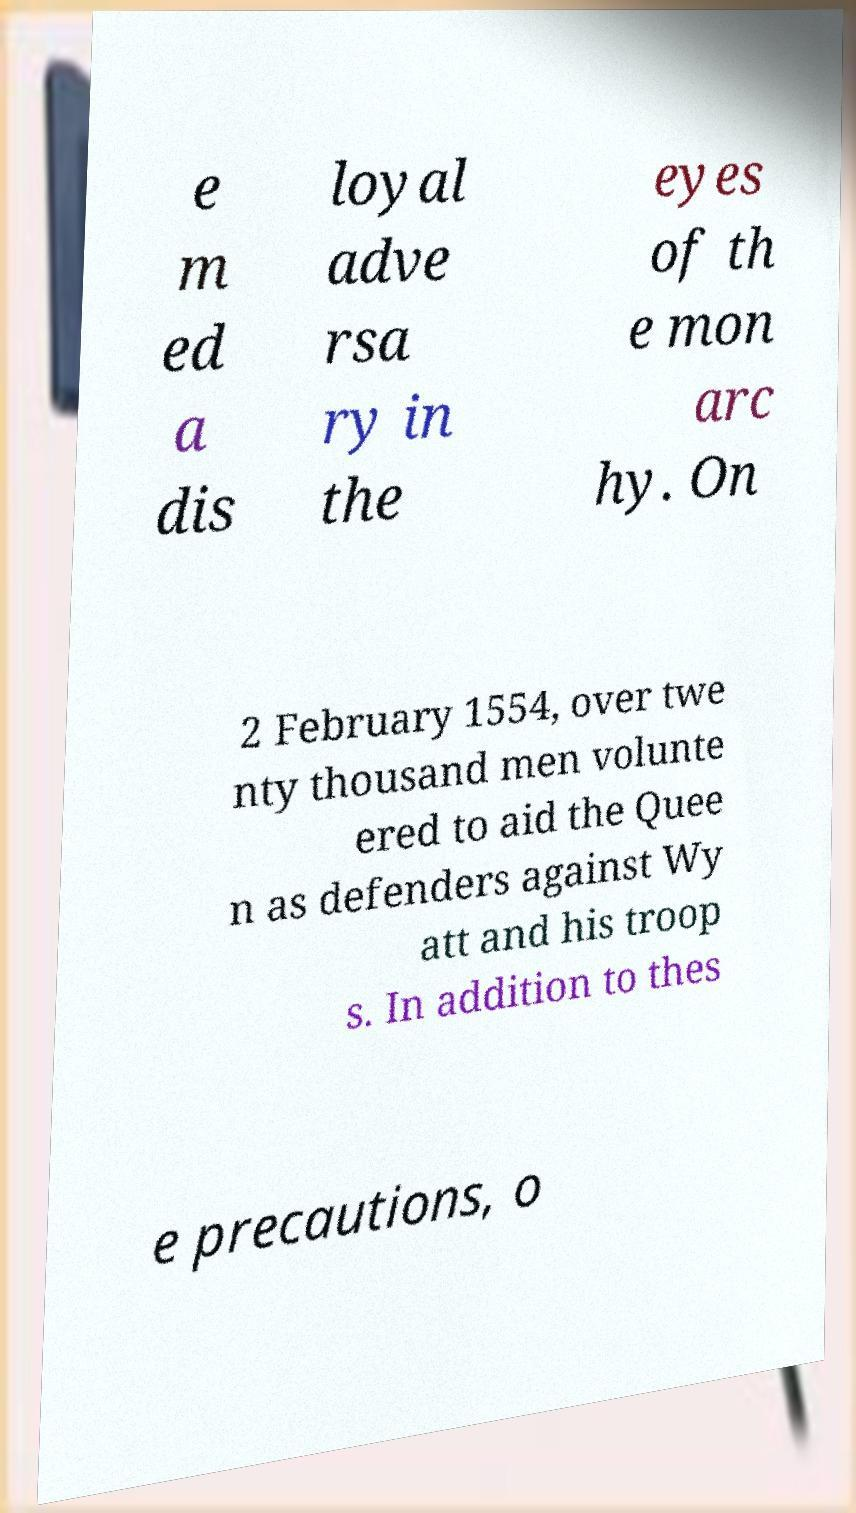Can you accurately transcribe the text from the provided image for me? e m ed a dis loyal adve rsa ry in the eyes of th e mon arc hy. On 2 February 1554, over twe nty thousand men volunte ered to aid the Quee n as defenders against Wy att and his troop s. In addition to thes e precautions, o 